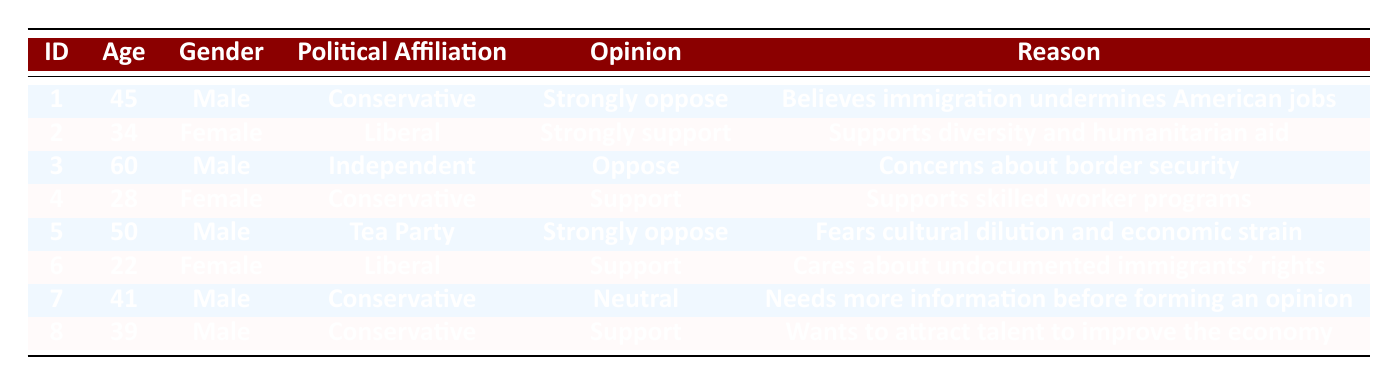What is the opinion on immigration of the respondent with ID 4? In the table, look for the row where the ID is 4. That respondent has the opinion of "Support" regarding immigration.
Answer: Support How many respondents strongly oppose immigration? By scanning the table for the "Opinion" column, I find two entries with "Strongly oppose," associated with respondents IDs 1 and 5. Therefore, there are two respondents who strongly oppose immigration.
Answer: 2 Is there a female respondent who supports immigration? The table shows female respondents, specifically IDs 2 and 6 have the opinion of "Strongly support" and "Support," respectively. Hence, there are female respondents who support immigration.
Answer: Yes What is the reason given by respondent ID 3 for opposing immigration? Looking at the table, in the row for respondent ID 3, the reason stated for the opinion "Oppose" is "Concerns about border security."
Answer: Concerns about border security How many conservatives have a neutral opinion on immigration? In the table, we look at respondents with the political affiliation "Conservative." There is only one conservative (ID 7) who has a "Neutral" opinion about immigration, indicating that there is one such respondent.
Answer: 1 What is the average age of respondents who strongly oppose immigration? The respondents who strongly oppose immigration are IDs 1 and 5, with ages 45 and 50, respectively. To find the average, I sum their ages (45 + 50 = 95) and divide by the number of respondents (2), resulting in an average age of 47.5.
Answer: 47.5 Do any respondents support immigration while being affiliated with the Conservative party? Scanning through the table, we find respondents 4 and 8, who identify as Conservative and have opinions of "Support." Thus, there are conservatives who support immigration.
Answer: Yes How many respondents have expressed a strong opinion (either for or against) on immigration? A strong opinion includes "Strongly oppose" or "Strongly support." In the table, IDs 1, 2, and 5 reflect a strong opinion. Thus, a total of three respondents have expressed a strong opinion on immigration.
Answer: 3 